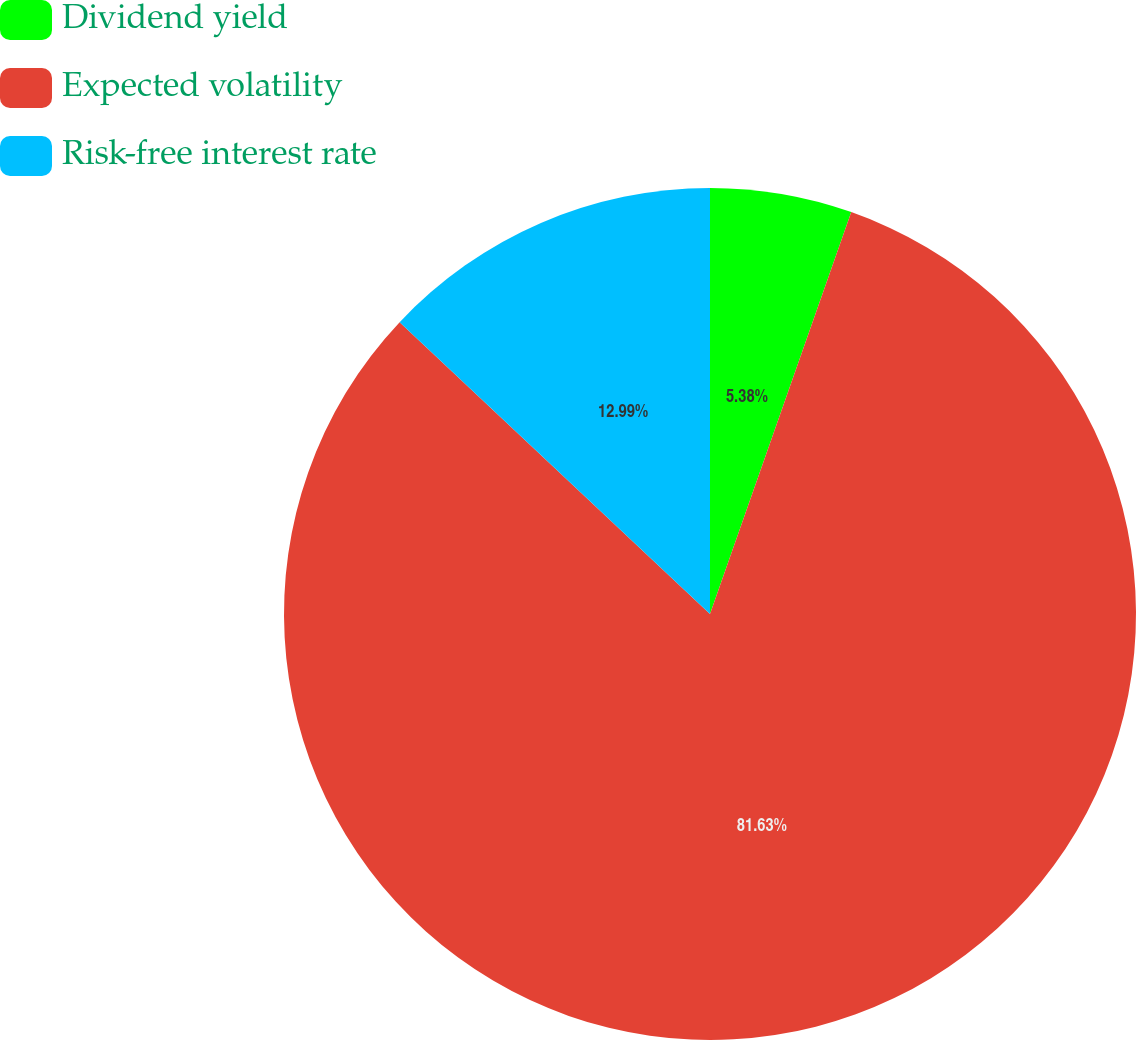Convert chart. <chart><loc_0><loc_0><loc_500><loc_500><pie_chart><fcel>Dividend yield<fcel>Expected volatility<fcel>Risk-free interest rate<nl><fcel>5.38%<fcel>81.63%<fcel>12.99%<nl></chart> 